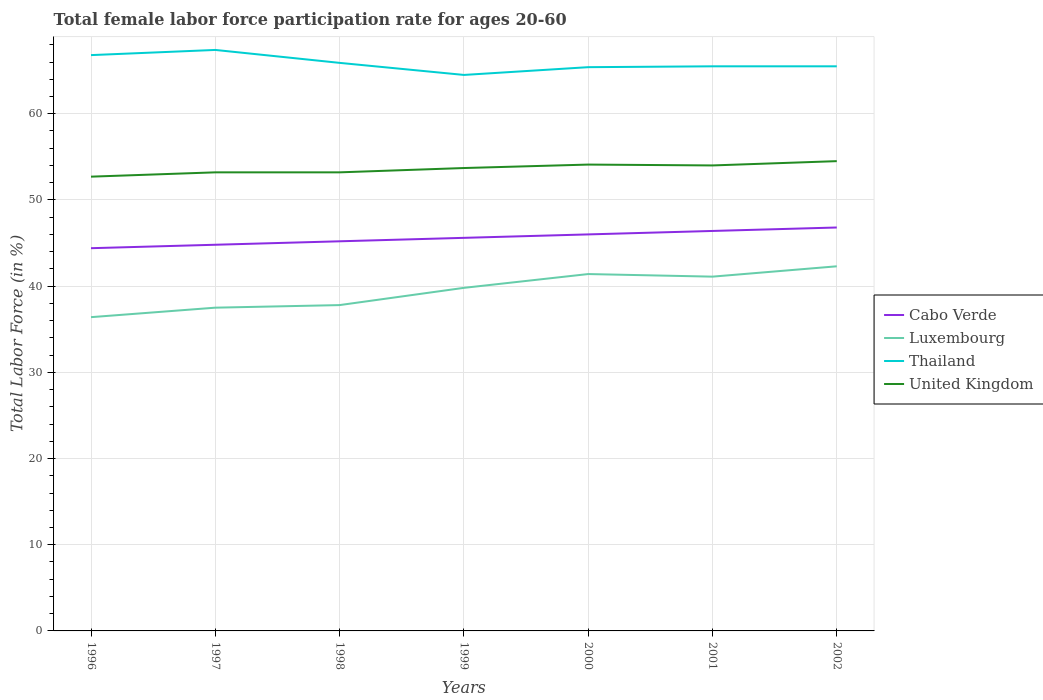How many different coloured lines are there?
Offer a terse response. 4. Is the number of lines equal to the number of legend labels?
Give a very brief answer. Yes. Across all years, what is the maximum female labor force participation rate in United Kingdom?
Provide a succinct answer. 52.7. In which year was the female labor force participation rate in Thailand maximum?
Give a very brief answer. 1999. What is the total female labor force participation rate in United Kingdom in the graph?
Keep it short and to the point. -0.3. What is the difference between the highest and the second highest female labor force participation rate in Thailand?
Your answer should be compact. 2.9. What is the difference between two consecutive major ticks on the Y-axis?
Provide a short and direct response. 10. Are the values on the major ticks of Y-axis written in scientific E-notation?
Provide a short and direct response. No. Does the graph contain grids?
Your answer should be compact. Yes. Where does the legend appear in the graph?
Offer a very short reply. Center right. How many legend labels are there?
Offer a terse response. 4. What is the title of the graph?
Keep it short and to the point. Total female labor force participation rate for ages 20-60. What is the label or title of the X-axis?
Offer a terse response. Years. What is the Total Labor Force (in %) in Cabo Verde in 1996?
Your answer should be compact. 44.4. What is the Total Labor Force (in %) of Luxembourg in 1996?
Make the answer very short. 36.4. What is the Total Labor Force (in %) of Thailand in 1996?
Ensure brevity in your answer.  66.8. What is the Total Labor Force (in %) in United Kingdom in 1996?
Provide a short and direct response. 52.7. What is the Total Labor Force (in %) of Cabo Verde in 1997?
Make the answer very short. 44.8. What is the Total Labor Force (in %) in Luxembourg in 1997?
Give a very brief answer. 37.5. What is the Total Labor Force (in %) in Thailand in 1997?
Keep it short and to the point. 67.4. What is the Total Labor Force (in %) of United Kingdom in 1997?
Your answer should be compact. 53.2. What is the Total Labor Force (in %) of Cabo Verde in 1998?
Provide a succinct answer. 45.2. What is the Total Labor Force (in %) of Luxembourg in 1998?
Offer a very short reply. 37.8. What is the Total Labor Force (in %) in Thailand in 1998?
Your response must be concise. 65.9. What is the Total Labor Force (in %) in United Kingdom in 1998?
Keep it short and to the point. 53.2. What is the Total Labor Force (in %) in Cabo Verde in 1999?
Keep it short and to the point. 45.6. What is the Total Labor Force (in %) of Luxembourg in 1999?
Your response must be concise. 39.8. What is the Total Labor Force (in %) in Thailand in 1999?
Offer a terse response. 64.5. What is the Total Labor Force (in %) in United Kingdom in 1999?
Your answer should be very brief. 53.7. What is the Total Labor Force (in %) in Luxembourg in 2000?
Provide a short and direct response. 41.4. What is the Total Labor Force (in %) in Thailand in 2000?
Your response must be concise. 65.4. What is the Total Labor Force (in %) in United Kingdom in 2000?
Your answer should be very brief. 54.1. What is the Total Labor Force (in %) in Cabo Verde in 2001?
Provide a succinct answer. 46.4. What is the Total Labor Force (in %) of Luxembourg in 2001?
Make the answer very short. 41.1. What is the Total Labor Force (in %) in Thailand in 2001?
Offer a terse response. 65.5. What is the Total Labor Force (in %) in Cabo Verde in 2002?
Your answer should be compact. 46.8. What is the Total Labor Force (in %) of Luxembourg in 2002?
Provide a succinct answer. 42.3. What is the Total Labor Force (in %) in Thailand in 2002?
Offer a terse response. 65.5. What is the Total Labor Force (in %) in United Kingdom in 2002?
Your answer should be compact. 54.5. Across all years, what is the maximum Total Labor Force (in %) in Cabo Verde?
Provide a succinct answer. 46.8. Across all years, what is the maximum Total Labor Force (in %) of Luxembourg?
Your response must be concise. 42.3. Across all years, what is the maximum Total Labor Force (in %) of Thailand?
Provide a short and direct response. 67.4. Across all years, what is the maximum Total Labor Force (in %) in United Kingdom?
Provide a succinct answer. 54.5. Across all years, what is the minimum Total Labor Force (in %) in Cabo Verde?
Give a very brief answer. 44.4. Across all years, what is the minimum Total Labor Force (in %) of Luxembourg?
Keep it short and to the point. 36.4. Across all years, what is the minimum Total Labor Force (in %) of Thailand?
Your answer should be very brief. 64.5. Across all years, what is the minimum Total Labor Force (in %) of United Kingdom?
Provide a short and direct response. 52.7. What is the total Total Labor Force (in %) of Cabo Verde in the graph?
Ensure brevity in your answer.  319.2. What is the total Total Labor Force (in %) in Luxembourg in the graph?
Offer a very short reply. 276.3. What is the total Total Labor Force (in %) of Thailand in the graph?
Your answer should be compact. 461. What is the total Total Labor Force (in %) of United Kingdom in the graph?
Make the answer very short. 375.4. What is the difference between the Total Labor Force (in %) of Cabo Verde in 1996 and that in 1997?
Provide a succinct answer. -0.4. What is the difference between the Total Labor Force (in %) of Luxembourg in 1996 and that in 1997?
Offer a terse response. -1.1. What is the difference between the Total Labor Force (in %) of Thailand in 1996 and that in 1997?
Provide a succinct answer. -0.6. What is the difference between the Total Labor Force (in %) in Cabo Verde in 1996 and that in 1998?
Provide a short and direct response. -0.8. What is the difference between the Total Labor Force (in %) in Luxembourg in 1996 and that in 1998?
Ensure brevity in your answer.  -1.4. What is the difference between the Total Labor Force (in %) in Thailand in 1996 and that in 1998?
Make the answer very short. 0.9. What is the difference between the Total Labor Force (in %) in United Kingdom in 1996 and that in 1998?
Keep it short and to the point. -0.5. What is the difference between the Total Labor Force (in %) of Thailand in 1996 and that in 1999?
Ensure brevity in your answer.  2.3. What is the difference between the Total Labor Force (in %) in Luxembourg in 1996 and that in 2000?
Make the answer very short. -5. What is the difference between the Total Labor Force (in %) in Luxembourg in 1996 and that in 2002?
Your answer should be very brief. -5.9. What is the difference between the Total Labor Force (in %) in United Kingdom in 1996 and that in 2002?
Your answer should be compact. -1.8. What is the difference between the Total Labor Force (in %) of Thailand in 1997 and that in 1998?
Ensure brevity in your answer.  1.5. What is the difference between the Total Labor Force (in %) in United Kingdom in 1997 and that in 1998?
Keep it short and to the point. 0. What is the difference between the Total Labor Force (in %) of Cabo Verde in 1997 and that in 1999?
Your answer should be compact. -0.8. What is the difference between the Total Labor Force (in %) of Luxembourg in 1997 and that in 1999?
Ensure brevity in your answer.  -2.3. What is the difference between the Total Labor Force (in %) in United Kingdom in 1997 and that in 2000?
Give a very brief answer. -0.9. What is the difference between the Total Labor Force (in %) of Cabo Verde in 1998 and that in 1999?
Provide a short and direct response. -0.4. What is the difference between the Total Labor Force (in %) of Luxembourg in 1998 and that in 1999?
Provide a succinct answer. -2. What is the difference between the Total Labor Force (in %) of Cabo Verde in 1998 and that in 2000?
Ensure brevity in your answer.  -0.8. What is the difference between the Total Labor Force (in %) in Luxembourg in 1998 and that in 2000?
Provide a short and direct response. -3.6. What is the difference between the Total Labor Force (in %) of Cabo Verde in 1998 and that in 2001?
Your answer should be compact. -1.2. What is the difference between the Total Labor Force (in %) of Luxembourg in 1998 and that in 2001?
Offer a very short reply. -3.3. What is the difference between the Total Labor Force (in %) in Thailand in 1998 and that in 2001?
Your response must be concise. 0.4. What is the difference between the Total Labor Force (in %) of United Kingdom in 1998 and that in 2001?
Your answer should be compact. -0.8. What is the difference between the Total Labor Force (in %) of Cabo Verde in 1998 and that in 2002?
Make the answer very short. -1.6. What is the difference between the Total Labor Force (in %) in Thailand in 1998 and that in 2002?
Provide a short and direct response. 0.4. What is the difference between the Total Labor Force (in %) of Luxembourg in 1999 and that in 2000?
Your answer should be very brief. -1.6. What is the difference between the Total Labor Force (in %) of United Kingdom in 1999 and that in 2000?
Your answer should be compact. -0.4. What is the difference between the Total Labor Force (in %) in Luxembourg in 1999 and that in 2001?
Give a very brief answer. -1.3. What is the difference between the Total Labor Force (in %) in Thailand in 1999 and that in 2001?
Your response must be concise. -1. What is the difference between the Total Labor Force (in %) in United Kingdom in 1999 and that in 2002?
Keep it short and to the point. -0.8. What is the difference between the Total Labor Force (in %) of Cabo Verde in 2000 and that in 2001?
Provide a short and direct response. -0.4. What is the difference between the Total Labor Force (in %) in Thailand in 2000 and that in 2001?
Offer a terse response. -0.1. What is the difference between the Total Labor Force (in %) of Cabo Verde in 2000 and that in 2002?
Your response must be concise. -0.8. What is the difference between the Total Labor Force (in %) in United Kingdom in 2000 and that in 2002?
Ensure brevity in your answer.  -0.4. What is the difference between the Total Labor Force (in %) of Cabo Verde in 2001 and that in 2002?
Keep it short and to the point. -0.4. What is the difference between the Total Labor Force (in %) of Luxembourg in 2001 and that in 2002?
Offer a terse response. -1.2. What is the difference between the Total Labor Force (in %) of Thailand in 2001 and that in 2002?
Your answer should be very brief. 0. What is the difference between the Total Labor Force (in %) in Cabo Verde in 1996 and the Total Labor Force (in %) in Luxembourg in 1997?
Offer a terse response. 6.9. What is the difference between the Total Labor Force (in %) in Cabo Verde in 1996 and the Total Labor Force (in %) in United Kingdom in 1997?
Your response must be concise. -8.8. What is the difference between the Total Labor Force (in %) in Luxembourg in 1996 and the Total Labor Force (in %) in Thailand in 1997?
Make the answer very short. -31. What is the difference between the Total Labor Force (in %) of Luxembourg in 1996 and the Total Labor Force (in %) of United Kingdom in 1997?
Keep it short and to the point. -16.8. What is the difference between the Total Labor Force (in %) in Thailand in 1996 and the Total Labor Force (in %) in United Kingdom in 1997?
Provide a succinct answer. 13.6. What is the difference between the Total Labor Force (in %) in Cabo Verde in 1996 and the Total Labor Force (in %) in Thailand in 1998?
Offer a very short reply. -21.5. What is the difference between the Total Labor Force (in %) in Cabo Verde in 1996 and the Total Labor Force (in %) in United Kingdom in 1998?
Provide a succinct answer. -8.8. What is the difference between the Total Labor Force (in %) of Luxembourg in 1996 and the Total Labor Force (in %) of Thailand in 1998?
Give a very brief answer. -29.5. What is the difference between the Total Labor Force (in %) in Luxembourg in 1996 and the Total Labor Force (in %) in United Kingdom in 1998?
Your answer should be very brief. -16.8. What is the difference between the Total Labor Force (in %) in Thailand in 1996 and the Total Labor Force (in %) in United Kingdom in 1998?
Ensure brevity in your answer.  13.6. What is the difference between the Total Labor Force (in %) of Cabo Verde in 1996 and the Total Labor Force (in %) of Thailand in 1999?
Provide a succinct answer. -20.1. What is the difference between the Total Labor Force (in %) of Luxembourg in 1996 and the Total Labor Force (in %) of Thailand in 1999?
Provide a short and direct response. -28.1. What is the difference between the Total Labor Force (in %) of Luxembourg in 1996 and the Total Labor Force (in %) of United Kingdom in 1999?
Give a very brief answer. -17.3. What is the difference between the Total Labor Force (in %) in Thailand in 1996 and the Total Labor Force (in %) in United Kingdom in 1999?
Provide a short and direct response. 13.1. What is the difference between the Total Labor Force (in %) of Cabo Verde in 1996 and the Total Labor Force (in %) of Luxembourg in 2000?
Your response must be concise. 3. What is the difference between the Total Labor Force (in %) in Cabo Verde in 1996 and the Total Labor Force (in %) in Thailand in 2000?
Your answer should be very brief. -21. What is the difference between the Total Labor Force (in %) in Cabo Verde in 1996 and the Total Labor Force (in %) in United Kingdom in 2000?
Offer a terse response. -9.7. What is the difference between the Total Labor Force (in %) in Luxembourg in 1996 and the Total Labor Force (in %) in Thailand in 2000?
Provide a short and direct response. -29. What is the difference between the Total Labor Force (in %) of Luxembourg in 1996 and the Total Labor Force (in %) of United Kingdom in 2000?
Your answer should be very brief. -17.7. What is the difference between the Total Labor Force (in %) in Cabo Verde in 1996 and the Total Labor Force (in %) in Luxembourg in 2001?
Give a very brief answer. 3.3. What is the difference between the Total Labor Force (in %) in Cabo Verde in 1996 and the Total Labor Force (in %) in Thailand in 2001?
Offer a terse response. -21.1. What is the difference between the Total Labor Force (in %) in Cabo Verde in 1996 and the Total Labor Force (in %) in United Kingdom in 2001?
Make the answer very short. -9.6. What is the difference between the Total Labor Force (in %) in Luxembourg in 1996 and the Total Labor Force (in %) in Thailand in 2001?
Make the answer very short. -29.1. What is the difference between the Total Labor Force (in %) in Luxembourg in 1996 and the Total Labor Force (in %) in United Kingdom in 2001?
Provide a short and direct response. -17.6. What is the difference between the Total Labor Force (in %) of Cabo Verde in 1996 and the Total Labor Force (in %) of Luxembourg in 2002?
Offer a very short reply. 2.1. What is the difference between the Total Labor Force (in %) in Cabo Verde in 1996 and the Total Labor Force (in %) in Thailand in 2002?
Give a very brief answer. -21.1. What is the difference between the Total Labor Force (in %) in Luxembourg in 1996 and the Total Labor Force (in %) in Thailand in 2002?
Keep it short and to the point. -29.1. What is the difference between the Total Labor Force (in %) in Luxembourg in 1996 and the Total Labor Force (in %) in United Kingdom in 2002?
Offer a terse response. -18.1. What is the difference between the Total Labor Force (in %) of Cabo Verde in 1997 and the Total Labor Force (in %) of Thailand in 1998?
Make the answer very short. -21.1. What is the difference between the Total Labor Force (in %) of Cabo Verde in 1997 and the Total Labor Force (in %) of United Kingdom in 1998?
Your response must be concise. -8.4. What is the difference between the Total Labor Force (in %) in Luxembourg in 1997 and the Total Labor Force (in %) in Thailand in 1998?
Your response must be concise. -28.4. What is the difference between the Total Labor Force (in %) of Luxembourg in 1997 and the Total Labor Force (in %) of United Kingdom in 1998?
Provide a succinct answer. -15.7. What is the difference between the Total Labor Force (in %) of Thailand in 1997 and the Total Labor Force (in %) of United Kingdom in 1998?
Ensure brevity in your answer.  14.2. What is the difference between the Total Labor Force (in %) of Cabo Verde in 1997 and the Total Labor Force (in %) of Thailand in 1999?
Offer a terse response. -19.7. What is the difference between the Total Labor Force (in %) of Cabo Verde in 1997 and the Total Labor Force (in %) of United Kingdom in 1999?
Provide a succinct answer. -8.9. What is the difference between the Total Labor Force (in %) of Luxembourg in 1997 and the Total Labor Force (in %) of United Kingdom in 1999?
Give a very brief answer. -16.2. What is the difference between the Total Labor Force (in %) of Thailand in 1997 and the Total Labor Force (in %) of United Kingdom in 1999?
Your response must be concise. 13.7. What is the difference between the Total Labor Force (in %) of Cabo Verde in 1997 and the Total Labor Force (in %) of Luxembourg in 2000?
Offer a terse response. 3.4. What is the difference between the Total Labor Force (in %) of Cabo Verde in 1997 and the Total Labor Force (in %) of Thailand in 2000?
Keep it short and to the point. -20.6. What is the difference between the Total Labor Force (in %) in Cabo Verde in 1997 and the Total Labor Force (in %) in United Kingdom in 2000?
Offer a very short reply. -9.3. What is the difference between the Total Labor Force (in %) of Luxembourg in 1997 and the Total Labor Force (in %) of Thailand in 2000?
Provide a short and direct response. -27.9. What is the difference between the Total Labor Force (in %) of Luxembourg in 1997 and the Total Labor Force (in %) of United Kingdom in 2000?
Offer a terse response. -16.6. What is the difference between the Total Labor Force (in %) in Cabo Verde in 1997 and the Total Labor Force (in %) in Luxembourg in 2001?
Provide a short and direct response. 3.7. What is the difference between the Total Labor Force (in %) of Cabo Verde in 1997 and the Total Labor Force (in %) of Thailand in 2001?
Make the answer very short. -20.7. What is the difference between the Total Labor Force (in %) of Cabo Verde in 1997 and the Total Labor Force (in %) of United Kingdom in 2001?
Offer a very short reply. -9.2. What is the difference between the Total Labor Force (in %) of Luxembourg in 1997 and the Total Labor Force (in %) of United Kingdom in 2001?
Make the answer very short. -16.5. What is the difference between the Total Labor Force (in %) in Cabo Verde in 1997 and the Total Labor Force (in %) in Thailand in 2002?
Keep it short and to the point. -20.7. What is the difference between the Total Labor Force (in %) in Luxembourg in 1997 and the Total Labor Force (in %) in United Kingdom in 2002?
Your answer should be compact. -17. What is the difference between the Total Labor Force (in %) of Thailand in 1997 and the Total Labor Force (in %) of United Kingdom in 2002?
Your answer should be compact. 12.9. What is the difference between the Total Labor Force (in %) in Cabo Verde in 1998 and the Total Labor Force (in %) in Luxembourg in 1999?
Provide a succinct answer. 5.4. What is the difference between the Total Labor Force (in %) in Cabo Verde in 1998 and the Total Labor Force (in %) in Thailand in 1999?
Your answer should be very brief. -19.3. What is the difference between the Total Labor Force (in %) of Cabo Verde in 1998 and the Total Labor Force (in %) of United Kingdom in 1999?
Give a very brief answer. -8.5. What is the difference between the Total Labor Force (in %) in Luxembourg in 1998 and the Total Labor Force (in %) in Thailand in 1999?
Make the answer very short. -26.7. What is the difference between the Total Labor Force (in %) in Luxembourg in 1998 and the Total Labor Force (in %) in United Kingdom in 1999?
Provide a succinct answer. -15.9. What is the difference between the Total Labor Force (in %) of Thailand in 1998 and the Total Labor Force (in %) of United Kingdom in 1999?
Keep it short and to the point. 12.2. What is the difference between the Total Labor Force (in %) in Cabo Verde in 1998 and the Total Labor Force (in %) in Luxembourg in 2000?
Ensure brevity in your answer.  3.8. What is the difference between the Total Labor Force (in %) in Cabo Verde in 1998 and the Total Labor Force (in %) in Thailand in 2000?
Ensure brevity in your answer.  -20.2. What is the difference between the Total Labor Force (in %) of Cabo Verde in 1998 and the Total Labor Force (in %) of United Kingdom in 2000?
Give a very brief answer. -8.9. What is the difference between the Total Labor Force (in %) in Luxembourg in 1998 and the Total Labor Force (in %) in Thailand in 2000?
Provide a short and direct response. -27.6. What is the difference between the Total Labor Force (in %) in Luxembourg in 1998 and the Total Labor Force (in %) in United Kingdom in 2000?
Your answer should be compact. -16.3. What is the difference between the Total Labor Force (in %) of Thailand in 1998 and the Total Labor Force (in %) of United Kingdom in 2000?
Offer a very short reply. 11.8. What is the difference between the Total Labor Force (in %) of Cabo Verde in 1998 and the Total Labor Force (in %) of Luxembourg in 2001?
Your answer should be very brief. 4.1. What is the difference between the Total Labor Force (in %) in Cabo Verde in 1998 and the Total Labor Force (in %) in Thailand in 2001?
Offer a terse response. -20.3. What is the difference between the Total Labor Force (in %) of Cabo Verde in 1998 and the Total Labor Force (in %) of United Kingdom in 2001?
Give a very brief answer. -8.8. What is the difference between the Total Labor Force (in %) in Luxembourg in 1998 and the Total Labor Force (in %) in Thailand in 2001?
Provide a short and direct response. -27.7. What is the difference between the Total Labor Force (in %) in Luxembourg in 1998 and the Total Labor Force (in %) in United Kingdom in 2001?
Your response must be concise. -16.2. What is the difference between the Total Labor Force (in %) of Thailand in 1998 and the Total Labor Force (in %) of United Kingdom in 2001?
Your answer should be very brief. 11.9. What is the difference between the Total Labor Force (in %) of Cabo Verde in 1998 and the Total Labor Force (in %) of Luxembourg in 2002?
Keep it short and to the point. 2.9. What is the difference between the Total Labor Force (in %) of Cabo Verde in 1998 and the Total Labor Force (in %) of Thailand in 2002?
Give a very brief answer. -20.3. What is the difference between the Total Labor Force (in %) of Luxembourg in 1998 and the Total Labor Force (in %) of Thailand in 2002?
Your response must be concise. -27.7. What is the difference between the Total Labor Force (in %) in Luxembourg in 1998 and the Total Labor Force (in %) in United Kingdom in 2002?
Your response must be concise. -16.7. What is the difference between the Total Labor Force (in %) in Cabo Verde in 1999 and the Total Labor Force (in %) in Luxembourg in 2000?
Your response must be concise. 4.2. What is the difference between the Total Labor Force (in %) in Cabo Verde in 1999 and the Total Labor Force (in %) in Thailand in 2000?
Provide a short and direct response. -19.8. What is the difference between the Total Labor Force (in %) of Cabo Verde in 1999 and the Total Labor Force (in %) of United Kingdom in 2000?
Your answer should be very brief. -8.5. What is the difference between the Total Labor Force (in %) of Luxembourg in 1999 and the Total Labor Force (in %) of Thailand in 2000?
Keep it short and to the point. -25.6. What is the difference between the Total Labor Force (in %) in Luxembourg in 1999 and the Total Labor Force (in %) in United Kingdom in 2000?
Offer a very short reply. -14.3. What is the difference between the Total Labor Force (in %) of Thailand in 1999 and the Total Labor Force (in %) of United Kingdom in 2000?
Make the answer very short. 10.4. What is the difference between the Total Labor Force (in %) of Cabo Verde in 1999 and the Total Labor Force (in %) of Luxembourg in 2001?
Your answer should be compact. 4.5. What is the difference between the Total Labor Force (in %) in Cabo Verde in 1999 and the Total Labor Force (in %) in Thailand in 2001?
Provide a succinct answer. -19.9. What is the difference between the Total Labor Force (in %) of Luxembourg in 1999 and the Total Labor Force (in %) of Thailand in 2001?
Your response must be concise. -25.7. What is the difference between the Total Labor Force (in %) of Cabo Verde in 1999 and the Total Labor Force (in %) of Luxembourg in 2002?
Your answer should be compact. 3.3. What is the difference between the Total Labor Force (in %) of Cabo Verde in 1999 and the Total Labor Force (in %) of Thailand in 2002?
Ensure brevity in your answer.  -19.9. What is the difference between the Total Labor Force (in %) of Luxembourg in 1999 and the Total Labor Force (in %) of Thailand in 2002?
Offer a terse response. -25.7. What is the difference between the Total Labor Force (in %) of Luxembourg in 1999 and the Total Labor Force (in %) of United Kingdom in 2002?
Give a very brief answer. -14.7. What is the difference between the Total Labor Force (in %) in Cabo Verde in 2000 and the Total Labor Force (in %) in Thailand in 2001?
Offer a very short reply. -19.5. What is the difference between the Total Labor Force (in %) in Cabo Verde in 2000 and the Total Labor Force (in %) in United Kingdom in 2001?
Keep it short and to the point. -8. What is the difference between the Total Labor Force (in %) of Luxembourg in 2000 and the Total Labor Force (in %) of Thailand in 2001?
Provide a short and direct response. -24.1. What is the difference between the Total Labor Force (in %) in Luxembourg in 2000 and the Total Labor Force (in %) in United Kingdom in 2001?
Provide a short and direct response. -12.6. What is the difference between the Total Labor Force (in %) of Thailand in 2000 and the Total Labor Force (in %) of United Kingdom in 2001?
Make the answer very short. 11.4. What is the difference between the Total Labor Force (in %) of Cabo Verde in 2000 and the Total Labor Force (in %) of Thailand in 2002?
Ensure brevity in your answer.  -19.5. What is the difference between the Total Labor Force (in %) of Cabo Verde in 2000 and the Total Labor Force (in %) of United Kingdom in 2002?
Your answer should be very brief. -8.5. What is the difference between the Total Labor Force (in %) in Luxembourg in 2000 and the Total Labor Force (in %) in Thailand in 2002?
Provide a short and direct response. -24.1. What is the difference between the Total Labor Force (in %) in Thailand in 2000 and the Total Labor Force (in %) in United Kingdom in 2002?
Ensure brevity in your answer.  10.9. What is the difference between the Total Labor Force (in %) in Cabo Verde in 2001 and the Total Labor Force (in %) in Thailand in 2002?
Your response must be concise. -19.1. What is the difference between the Total Labor Force (in %) in Cabo Verde in 2001 and the Total Labor Force (in %) in United Kingdom in 2002?
Make the answer very short. -8.1. What is the difference between the Total Labor Force (in %) of Luxembourg in 2001 and the Total Labor Force (in %) of Thailand in 2002?
Offer a terse response. -24.4. What is the average Total Labor Force (in %) in Cabo Verde per year?
Offer a very short reply. 45.6. What is the average Total Labor Force (in %) in Luxembourg per year?
Offer a very short reply. 39.47. What is the average Total Labor Force (in %) in Thailand per year?
Your response must be concise. 65.86. What is the average Total Labor Force (in %) of United Kingdom per year?
Provide a short and direct response. 53.63. In the year 1996, what is the difference between the Total Labor Force (in %) in Cabo Verde and Total Labor Force (in %) in Thailand?
Offer a very short reply. -22.4. In the year 1996, what is the difference between the Total Labor Force (in %) of Cabo Verde and Total Labor Force (in %) of United Kingdom?
Your answer should be very brief. -8.3. In the year 1996, what is the difference between the Total Labor Force (in %) in Luxembourg and Total Labor Force (in %) in Thailand?
Your response must be concise. -30.4. In the year 1996, what is the difference between the Total Labor Force (in %) in Luxembourg and Total Labor Force (in %) in United Kingdom?
Offer a very short reply. -16.3. In the year 1996, what is the difference between the Total Labor Force (in %) of Thailand and Total Labor Force (in %) of United Kingdom?
Keep it short and to the point. 14.1. In the year 1997, what is the difference between the Total Labor Force (in %) of Cabo Verde and Total Labor Force (in %) of Thailand?
Keep it short and to the point. -22.6. In the year 1997, what is the difference between the Total Labor Force (in %) of Cabo Verde and Total Labor Force (in %) of United Kingdom?
Offer a terse response. -8.4. In the year 1997, what is the difference between the Total Labor Force (in %) of Luxembourg and Total Labor Force (in %) of Thailand?
Provide a short and direct response. -29.9. In the year 1997, what is the difference between the Total Labor Force (in %) of Luxembourg and Total Labor Force (in %) of United Kingdom?
Ensure brevity in your answer.  -15.7. In the year 1997, what is the difference between the Total Labor Force (in %) of Thailand and Total Labor Force (in %) of United Kingdom?
Your answer should be very brief. 14.2. In the year 1998, what is the difference between the Total Labor Force (in %) of Cabo Verde and Total Labor Force (in %) of Thailand?
Offer a terse response. -20.7. In the year 1998, what is the difference between the Total Labor Force (in %) of Cabo Verde and Total Labor Force (in %) of United Kingdom?
Provide a short and direct response. -8. In the year 1998, what is the difference between the Total Labor Force (in %) of Luxembourg and Total Labor Force (in %) of Thailand?
Make the answer very short. -28.1. In the year 1998, what is the difference between the Total Labor Force (in %) in Luxembourg and Total Labor Force (in %) in United Kingdom?
Provide a succinct answer. -15.4. In the year 1998, what is the difference between the Total Labor Force (in %) in Thailand and Total Labor Force (in %) in United Kingdom?
Your answer should be very brief. 12.7. In the year 1999, what is the difference between the Total Labor Force (in %) in Cabo Verde and Total Labor Force (in %) in Luxembourg?
Offer a very short reply. 5.8. In the year 1999, what is the difference between the Total Labor Force (in %) of Cabo Verde and Total Labor Force (in %) of Thailand?
Offer a very short reply. -18.9. In the year 1999, what is the difference between the Total Labor Force (in %) in Cabo Verde and Total Labor Force (in %) in United Kingdom?
Your answer should be very brief. -8.1. In the year 1999, what is the difference between the Total Labor Force (in %) in Luxembourg and Total Labor Force (in %) in Thailand?
Your response must be concise. -24.7. In the year 1999, what is the difference between the Total Labor Force (in %) of Luxembourg and Total Labor Force (in %) of United Kingdom?
Keep it short and to the point. -13.9. In the year 1999, what is the difference between the Total Labor Force (in %) in Thailand and Total Labor Force (in %) in United Kingdom?
Ensure brevity in your answer.  10.8. In the year 2000, what is the difference between the Total Labor Force (in %) of Cabo Verde and Total Labor Force (in %) of Thailand?
Keep it short and to the point. -19.4. In the year 2000, what is the difference between the Total Labor Force (in %) in Cabo Verde and Total Labor Force (in %) in United Kingdom?
Your answer should be very brief. -8.1. In the year 2000, what is the difference between the Total Labor Force (in %) of Luxembourg and Total Labor Force (in %) of United Kingdom?
Provide a short and direct response. -12.7. In the year 2001, what is the difference between the Total Labor Force (in %) of Cabo Verde and Total Labor Force (in %) of Thailand?
Your response must be concise. -19.1. In the year 2001, what is the difference between the Total Labor Force (in %) of Luxembourg and Total Labor Force (in %) of Thailand?
Ensure brevity in your answer.  -24.4. In the year 2002, what is the difference between the Total Labor Force (in %) in Cabo Verde and Total Labor Force (in %) in Thailand?
Provide a short and direct response. -18.7. In the year 2002, what is the difference between the Total Labor Force (in %) of Luxembourg and Total Labor Force (in %) of Thailand?
Your response must be concise. -23.2. What is the ratio of the Total Labor Force (in %) of Luxembourg in 1996 to that in 1997?
Your response must be concise. 0.97. What is the ratio of the Total Labor Force (in %) in United Kingdom in 1996 to that in 1997?
Your response must be concise. 0.99. What is the ratio of the Total Labor Force (in %) of Cabo Verde in 1996 to that in 1998?
Ensure brevity in your answer.  0.98. What is the ratio of the Total Labor Force (in %) in Luxembourg in 1996 to that in 1998?
Offer a terse response. 0.96. What is the ratio of the Total Labor Force (in %) in Thailand in 1996 to that in 1998?
Your answer should be compact. 1.01. What is the ratio of the Total Labor Force (in %) of United Kingdom in 1996 to that in 1998?
Your answer should be very brief. 0.99. What is the ratio of the Total Labor Force (in %) of Cabo Verde in 1996 to that in 1999?
Your answer should be very brief. 0.97. What is the ratio of the Total Labor Force (in %) of Luxembourg in 1996 to that in 1999?
Your answer should be very brief. 0.91. What is the ratio of the Total Labor Force (in %) in Thailand in 1996 to that in 1999?
Ensure brevity in your answer.  1.04. What is the ratio of the Total Labor Force (in %) in United Kingdom in 1996 to that in 1999?
Keep it short and to the point. 0.98. What is the ratio of the Total Labor Force (in %) of Cabo Verde in 1996 to that in 2000?
Provide a short and direct response. 0.97. What is the ratio of the Total Labor Force (in %) of Luxembourg in 1996 to that in 2000?
Make the answer very short. 0.88. What is the ratio of the Total Labor Force (in %) in Thailand in 1996 to that in 2000?
Provide a succinct answer. 1.02. What is the ratio of the Total Labor Force (in %) of United Kingdom in 1996 to that in 2000?
Your answer should be very brief. 0.97. What is the ratio of the Total Labor Force (in %) in Cabo Verde in 1996 to that in 2001?
Ensure brevity in your answer.  0.96. What is the ratio of the Total Labor Force (in %) of Luxembourg in 1996 to that in 2001?
Provide a succinct answer. 0.89. What is the ratio of the Total Labor Force (in %) of Thailand in 1996 to that in 2001?
Your answer should be compact. 1.02. What is the ratio of the Total Labor Force (in %) in United Kingdom in 1996 to that in 2001?
Keep it short and to the point. 0.98. What is the ratio of the Total Labor Force (in %) of Cabo Verde in 1996 to that in 2002?
Offer a very short reply. 0.95. What is the ratio of the Total Labor Force (in %) of Luxembourg in 1996 to that in 2002?
Offer a very short reply. 0.86. What is the ratio of the Total Labor Force (in %) in Thailand in 1996 to that in 2002?
Give a very brief answer. 1.02. What is the ratio of the Total Labor Force (in %) in Luxembourg in 1997 to that in 1998?
Provide a short and direct response. 0.99. What is the ratio of the Total Labor Force (in %) of Thailand in 1997 to that in 1998?
Keep it short and to the point. 1.02. What is the ratio of the Total Labor Force (in %) in United Kingdom in 1997 to that in 1998?
Provide a short and direct response. 1. What is the ratio of the Total Labor Force (in %) in Cabo Verde in 1997 to that in 1999?
Make the answer very short. 0.98. What is the ratio of the Total Labor Force (in %) of Luxembourg in 1997 to that in 1999?
Your response must be concise. 0.94. What is the ratio of the Total Labor Force (in %) of Thailand in 1997 to that in 1999?
Make the answer very short. 1.04. What is the ratio of the Total Labor Force (in %) of Cabo Verde in 1997 to that in 2000?
Give a very brief answer. 0.97. What is the ratio of the Total Labor Force (in %) of Luxembourg in 1997 to that in 2000?
Keep it short and to the point. 0.91. What is the ratio of the Total Labor Force (in %) of Thailand in 1997 to that in 2000?
Provide a short and direct response. 1.03. What is the ratio of the Total Labor Force (in %) in United Kingdom in 1997 to that in 2000?
Give a very brief answer. 0.98. What is the ratio of the Total Labor Force (in %) of Cabo Verde in 1997 to that in 2001?
Make the answer very short. 0.97. What is the ratio of the Total Labor Force (in %) in Luxembourg in 1997 to that in 2001?
Provide a succinct answer. 0.91. What is the ratio of the Total Labor Force (in %) in Thailand in 1997 to that in 2001?
Offer a terse response. 1.03. What is the ratio of the Total Labor Force (in %) in United Kingdom in 1997 to that in 2001?
Offer a terse response. 0.99. What is the ratio of the Total Labor Force (in %) in Cabo Verde in 1997 to that in 2002?
Your response must be concise. 0.96. What is the ratio of the Total Labor Force (in %) of Luxembourg in 1997 to that in 2002?
Make the answer very short. 0.89. What is the ratio of the Total Labor Force (in %) in Thailand in 1997 to that in 2002?
Provide a succinct answer. 1.03. What is the ratio of the Total Labor Force (in %) in United Kingdom in 1997 to that in 2002?
Keep it short and to the point. 0.98. What is the ratio of the Total Labor Force (in %) of Cabo Verde in 1998 to that in 1999?
Your answer should be very brief. 0.99. What is the ratio of the Total Labor Force (in %) in Luxembourg in 1998 to that in 1999?
Your response must be concise. 0.95. What is the ratio of the Total Labor Force (in %) in Thailand in 1998 to that in 1999?
Offer a very short reply. 1.02. What is the ratio of the Total Labor Force (in %) in Cabo Verde in 1998 to that in 2000?
Offer a very short reply. 0.98. What is the ratio of the Total Labor Force (in %) of Luxembourg in 1998 to that in 2000?
Make the answer very short. 0.91. What is the ratio of the Total Labor Force (in %) of Thailand in 1998 to that in 2000?
Give a very brief answer. 1.01. What is the ratio of the Total Labor Force (in %) in United Kingdom in 1998 to that in 2000?
Keep it short and to the point. 0.98. What is the ratio of the Total Labor Force (in %) in Cabo Verde in 1998 to that in 2001?
Keep it short and to the point. 0.97. What is the ratio of the Total Labor Force (in %) of Luxembourg in 1998 to that in 2001?
Ensure brevity in your answer.  0.92. What is the ratio of the Total Labor Force (in %) in United Kingdom in 1998 to that in 2001?
Offer a very short reply. 0.99. What is the ratio of the Total Labor Force (in %) in Cabo Verde in 1998 to that in 2002?
Make the answer very short. 0.97. What is the ratio of the Total Labor Force (in %) in Luxembourg in 1998 to that in 2002?
Keep it short and to the point. 0.89. What is the ratio of the Total Labor Force (in %) in Thailand in 1998 to that in 2002?
Your response must be concise. 1.01. What is the ratio of the Total Labor Force (in %) of United Kingdom in 1998 to that in 2002?
Offer a terse response. 0.98. What is the ratio of the Total Labor Force (in %) in Luxembourg in 1999 to that in 2000?
Ensure brevity in your answer.  0.96. What is the ratio of the Total Labor Force (in %) of Thailand in 1999 to that in 2000?
Make the answer very short. 0.99. What is the ratio of the Total Labor Force (in %) in United Kingdom in 1999 to that in 2000?
Provide a succinct answer. 0.99. What is the ratio of the Total Labor Force (in %) in Cabo Verde in 1999 to that in 2001?
Provide a short and direct response. 0.98. What is the ratio of the Total Labor Force (in %) in Luxembourg in 1999 to that in 2001?
Your response must be concise. 0.97. What is the ratio of the Total Labor Force (in %) of Thailand in 1999 to that in 2001?
Your answer should be compact. 0.98. What is the ratio of the Total Labor Force (in %) of Cabo Verde in 1999 to that in 2002?
Provide a succinct answer. 0.97. What is the ratio of the Total Labor Force (in %) in Luxembourg in 1999 to that in 2002?
Give a very brief answer. 0.94. What is the ratio of the Total Labor Force (in %) of Thailand in 1999 to that in 2002?
Your response must be concise. 0.98. What is the ratio of the Total Labor Force (in %) of United Kingdom in 1999 to that in 2002?
Ensure brevity in your answer.  0.99. What is the ratio of the Total Labor Force (in %) of Luxembourg in 2000 to that in 2001?
Provide a succinct answer. 1.01. What is the ratio of the Total Labor Force (in %) in Thailand in 2000 to that in 2001?
Make the answer very short. 1. What is the ratio of the Total Labor Force (in %) of Cabo Verde in 2000 to that in 2002?
Provide a short and direct response. 0.98. What is the ratio of the Total Labor Force (in %) of Luxembourg in 2000 to that in 2002?
Your answer should be compact. 0.98. What is the ratio of the Total Labor Force (in %) in Thailand in 2000 to that in 2002?
Keep it short and to the point. 1. What is the ratio of the Total Labor Force (in %) in Luxembourg in 2001 to that in 2002?
Provide a succinct answer. 0.97. What is the ratio of the Total Labor Force (in %) of Thailand in 2001 to that in 2002?
Keep it short and to the point. 1. What is the difference between the highest and the second highest Total Labor Force (in %) in Luxembourg?
Your response must be concise. 0.9. What is the difference between the highest and the second highest Total Labor Force (in %) of Thailand?
Make the answer very short. 0.6. What is the difference between the highest and the second highest Total Labor Force (in %) in United Kingdom?
Your answer should be compact. 0.4. What is the difference between the highest and the lowest Total Labor Force (in %) in Cabo Verde?
Give a very brief answer. 2.4. 